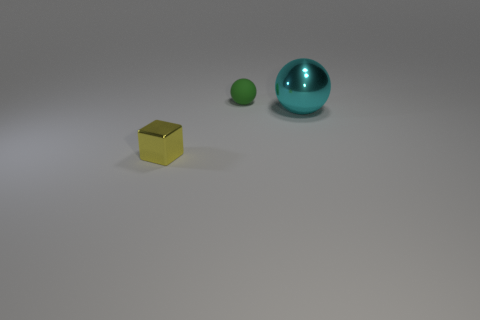What is the shape of the thing that is in front of the sphere that is to the right of the tiny object that is behind the tiny metallic block?
Give a very brief answer. Cube. There is a shiny thing that is behind the tiny block; how big is it?
Give a very brief answer. Large. The green matte thing that is the same size as the yellow shiny thing is what shape?
Provide a succinct answer. Sphere. How many things are either tiny matte cubes or things that are in front of the cyan metal object?
Provide a short and direct response. 1. How many tiny rubber objects are in front of the shiny object that is behind the metal object in front of the big metallic ball?
Ensure brevity in your answer.  0. The big sphere that is made of the same material as the block is what color?
Offer a very short reply. Cyan. There is a shiny thing that is on the right side of the yellow cube; is its size the same as the tiny green object?
Provide a short and direct response. No. How many objects are large green shiny objects or large shiny things?
Your answer should be compact. 1. What material is the ball that is behind the ball to the right of the sphere that is behind the big cyan shiny thing made of?
Give a very brief answer. Rubber. What is the material of the sphere behind the cyan metallic object?
Offer a very short reply. Rubber. 